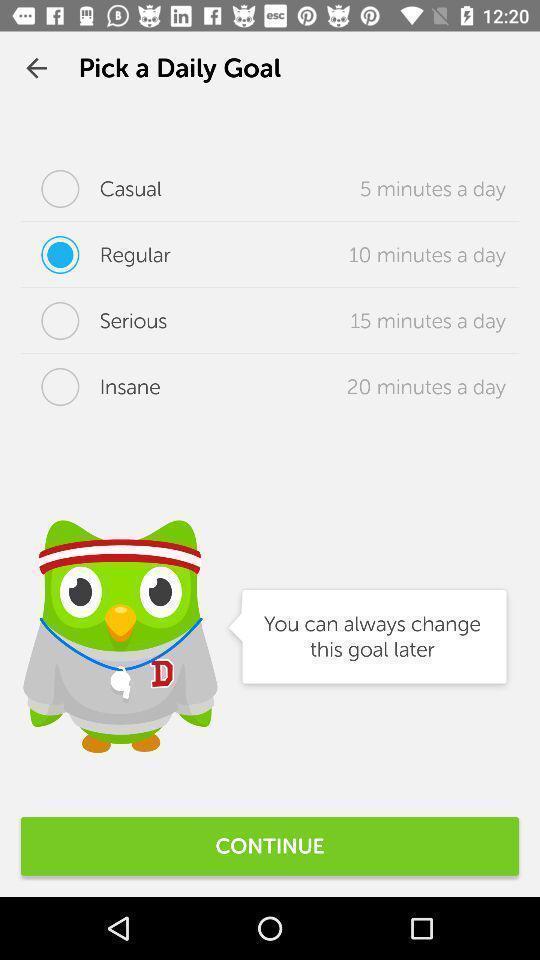Describe the visual elements of this screenshot. Page displaying to select daily goal in app. 